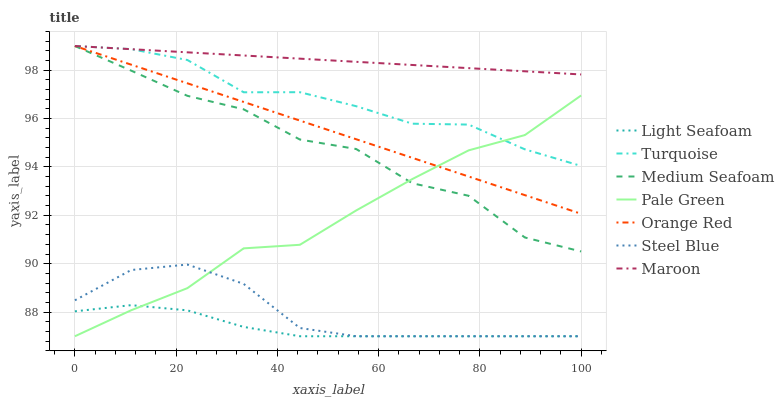Does Light Seafoam have the minimum area under the curve?
Answer yes or no. Yes. Does Maroon have the maximum area under the curve?
Answer yes or no. Yes. Does Steel Blue have the minimum area under the curve?
Answer yes or no. No. Does Steel Blue have the maximum area under the curve?
Answer yes or no. No. Is Maroon the smoothest?
Answer yes or no. Yes. Is Medium Seafoam the roughest?
Answer yes or no. Yes. Is Steel Blue the smoothest?
Answer yes or no. No. Is Steel Blue the roughest?
Answer yes or no. No. Does Steel Blue have the lowest value?
Answer yes or no. Yes. Does Maroon have the lowest value?
Answer yes or no. No. Does Medium Seafoam have the highest value?
Answer yes or no. Yes. Does Steel Blue have the highest value?
Answer yes or no. No. Is Light Seafoam less than Medium Seafoam?
Answer yes or no. Yes. Is Turquoise greater than Steel Blue?
Answer yes or no. Yes. Does Maroon intersect Turquoise?
Answer yes or no. Yes. Is Maroon less than Turquoise?
Answer yes or no. No. Is Maroon greater than Turquoise?
Answer yes or no. No. Does Light Seafoam intersect Medium Seafoam?
Answer yes or no. No. 